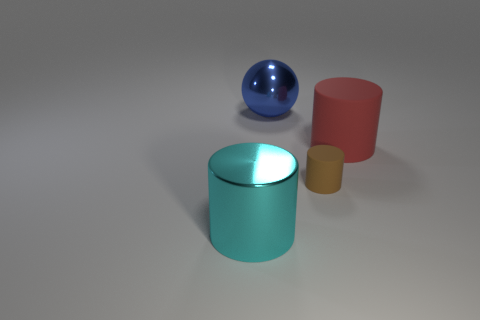Is the big red object made of the same material as the brown object?
Your answer should be very brief. Yes. How many other objects are there of the same shape as the big blue object?
Ensure brevity in your answer.  0. What size is the thing that is behind the tiny brown matte cylinder and left of the brown cylinder?
Your answer should be very brief. Large. How many shiny things are small yellow balls or big blue objects?
Keep it short and to the point. 1. There is a matte object that is on the right side of the small brown cylinder; does it have the same shape as the big metal object that is to the right of the cyan metallic object?
Provide a succinct answer. No. Is there a ball that has the same material as the cyan thing?
Make the answer very short. Yes. The tiny rubber object is what color?
Give a very brief answer. Brown. There is a metallic object that is on the left side of the ball; what is its size?
Your answer should be compact. Large. How many things are the same color as the sphere?
Offer a terse response. 0. There is a large metal object behind the large cyan metallic thing; are there any cyan cylinders on the right side of it?
Keep it short and to the point. No. 